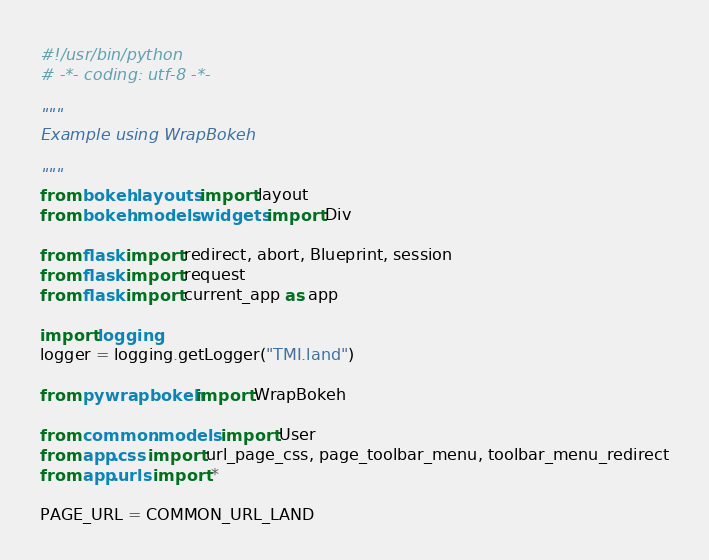<code> <loc_0><loc_0><loc_500><loc_500><_Python_>#!/usr/bin/python
# -*- coding: utf-8 -*-

"""
Example using WrapBokeh

"""
from bokeh.layouts import layout
from bokeh.models.widgets import Div

from flask import redirect, abort, Blueprint, session
from flask import request
from flask import current_app as app

import logging
logger = logging.getLogger("TMI.land")

from pywrapbokeh import WrapBokeh

from common.models import User
from app.css import url_page_css, page_toolbar_menu, toolbar_menu_redirect
from app.urls import *

PAGE_URL = COMMON_URL_LAND
</code> 